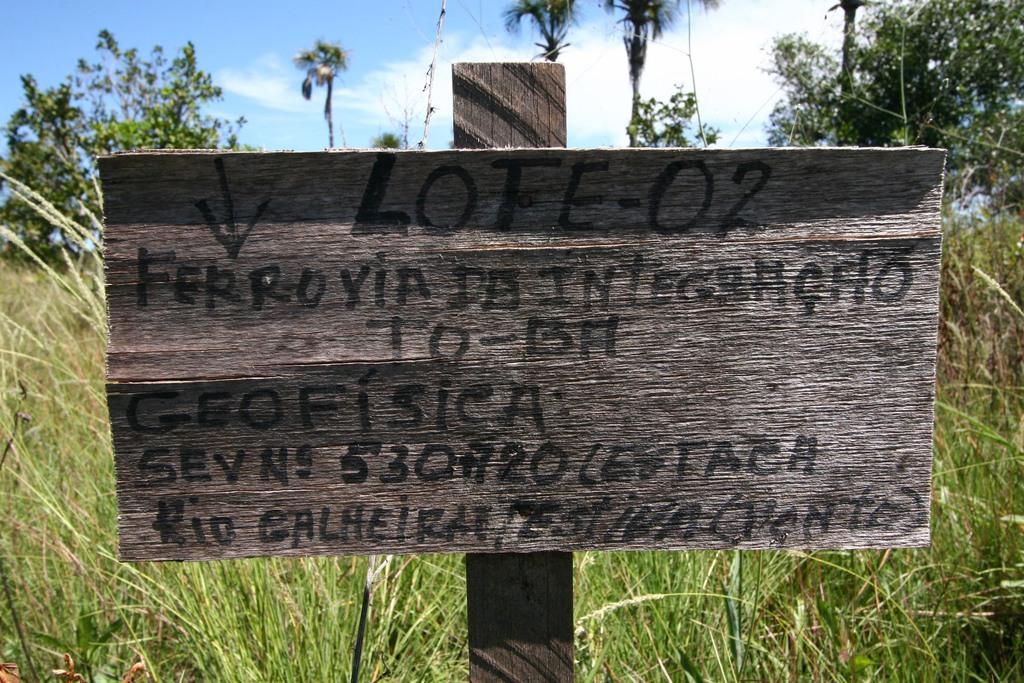Can you describe this image briefly? In this image there is a board attached to the wooden plank. On the board there is some text on it. Behind the board there is some grass on the land having few trees. Top of the image there is sky. 